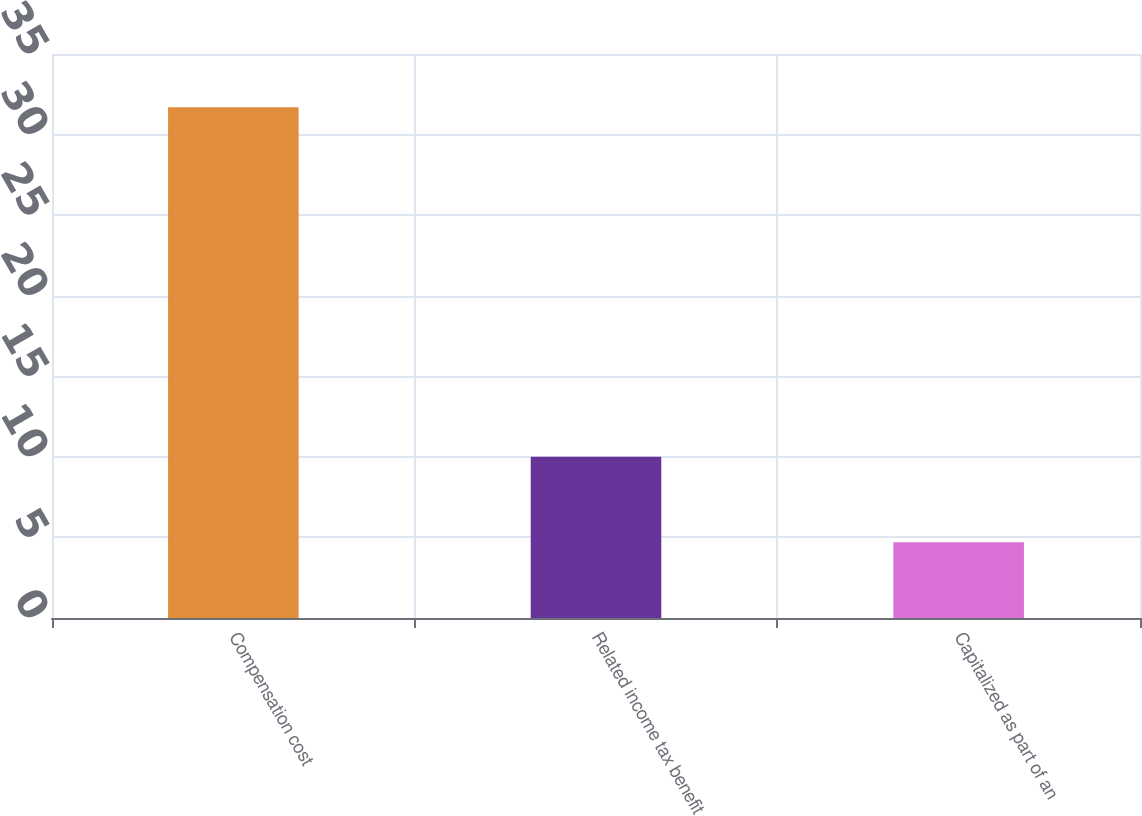Convert chart to OTSL. <chart><loc_0><loc_0><loc_500><loc_500><bar_chart><fcel>Compensation cost<fcel>Related income tax benefit<fcel>Capitalized as part of an<nl><fcel>31.7<fcel>10<fcel>4.7<nl></chart> 